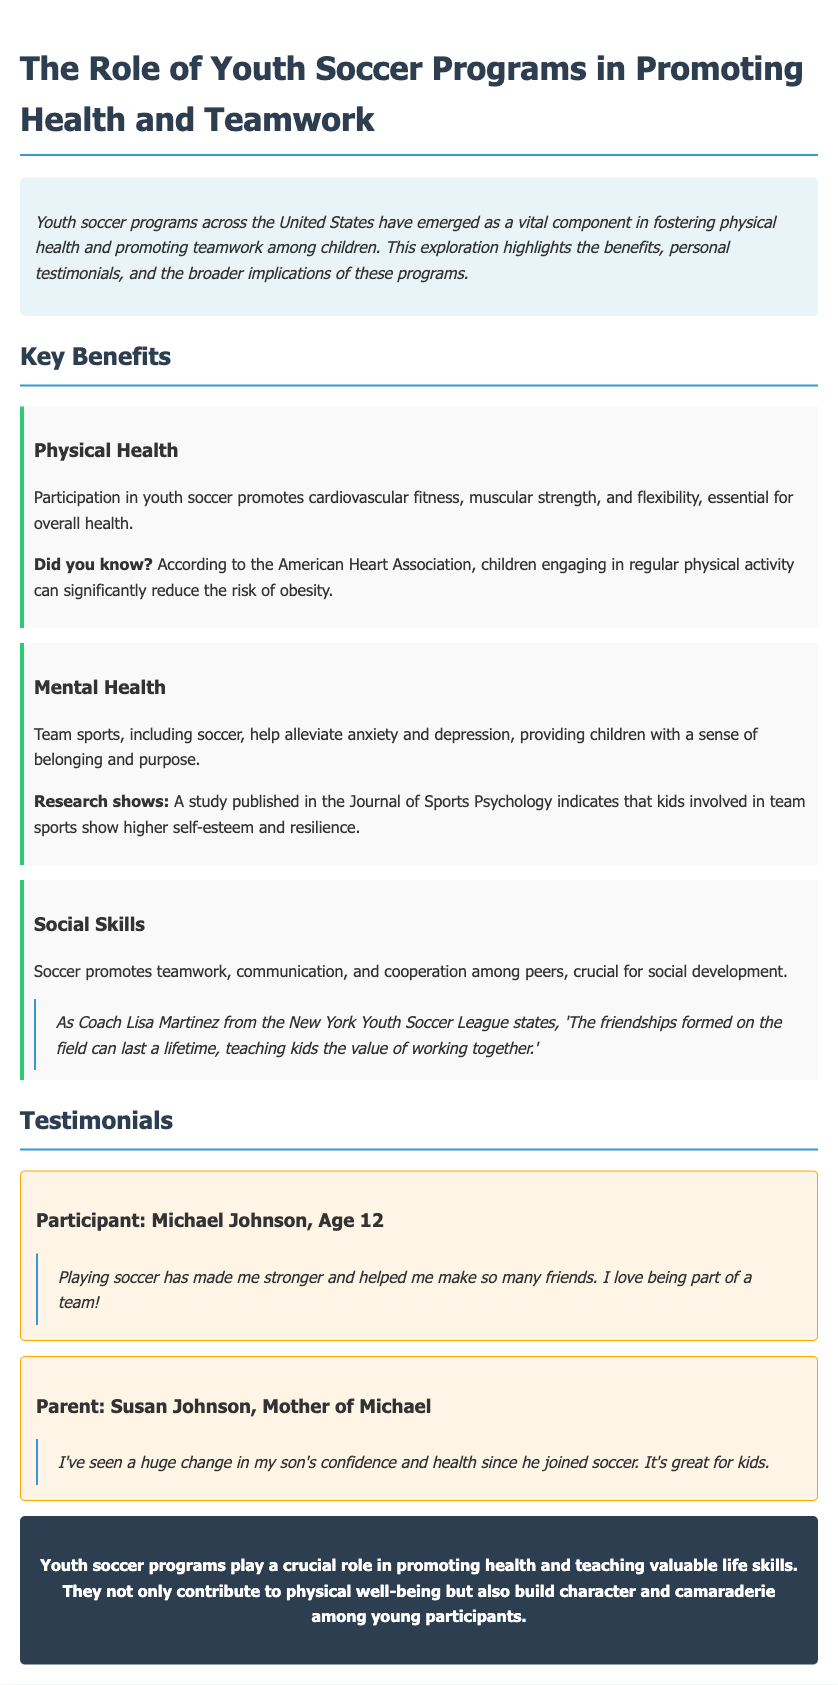What is the title of the document? The title is stated in the header section of the document.
Answer: Youth Soccer Programs: Promoting Health and Teamwork What age group does Michael Johnson belong to? The participant's age is provided in the testimonial section.
Answer: 12 Who is the author of the testimonial from the parent? The parent’s name is included in the testimonial section.
Answer: Susan Johnson What is one benefit of youth soccer related to mental health? The document lists several benefits of soccer, including one on mental health.
Answer: Alleviate anxiety According to the document, what does soccer help build among young participants? The conclusion sums up the contributions of soccer programs mentioned in the document.
Answer: Character Which organization is mentioned for providing statistics on physical activity? The document cites an organization that highlights the importance of physical activity for children.
Answer: American Heart Association What is a key aspect of social development promoted by soccer? The social skills section highlights an important aspect of teamwork through soccer.
Answer: Cooperation How does soccer contribute to children's self-esteem? A study related to mental health is referenced in the benefits section.
Answer: Higher self-esteem Who stated that friendships formed on the field can last a lifetime? The quote highlighted in the social skills section names the speaker.
Answer: Coach Lisa Martinez 